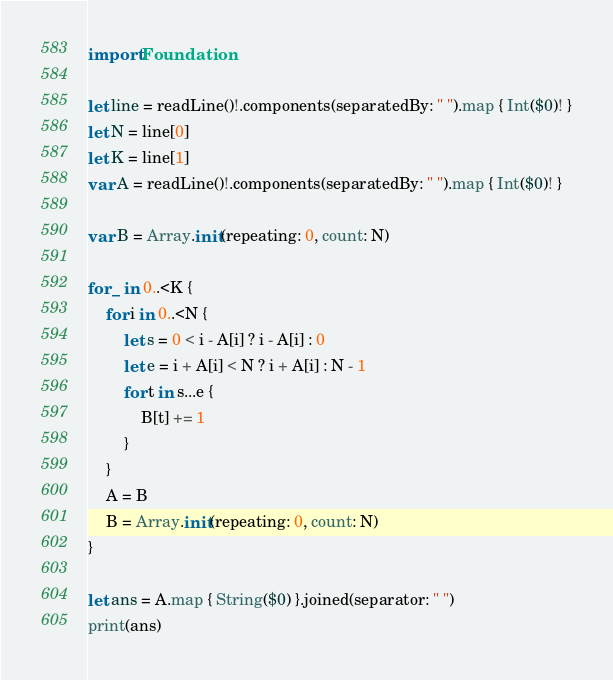Convert code to text. <code><loc_0><loc_0><loc_500><loc_500><_Swift_>import Foundation

let line = readLine()!.components(separatedBy: " ").map { Int($0)! }
let N = line[0]
let K = line[1]
var A = readLine()!.components(separatedBy: " ").map { Int($0)! }

var B = Array.init(repeating: 0, count: N)

for _ in 0..<K {
    for i in 0..<N {
        let s = 0 < i - A[i] ? i - A[i] : 0
        let e = i + A[i] < N ? i + A[i] : N - 1
        for t in s...e {
            B[t] += 1
        }
    }
    A = B
    B = Array.init(repeating: 0, count: N)
}

let ans = A.map { String($0) }.joined(separator: " ")
print(ans)
</code> 